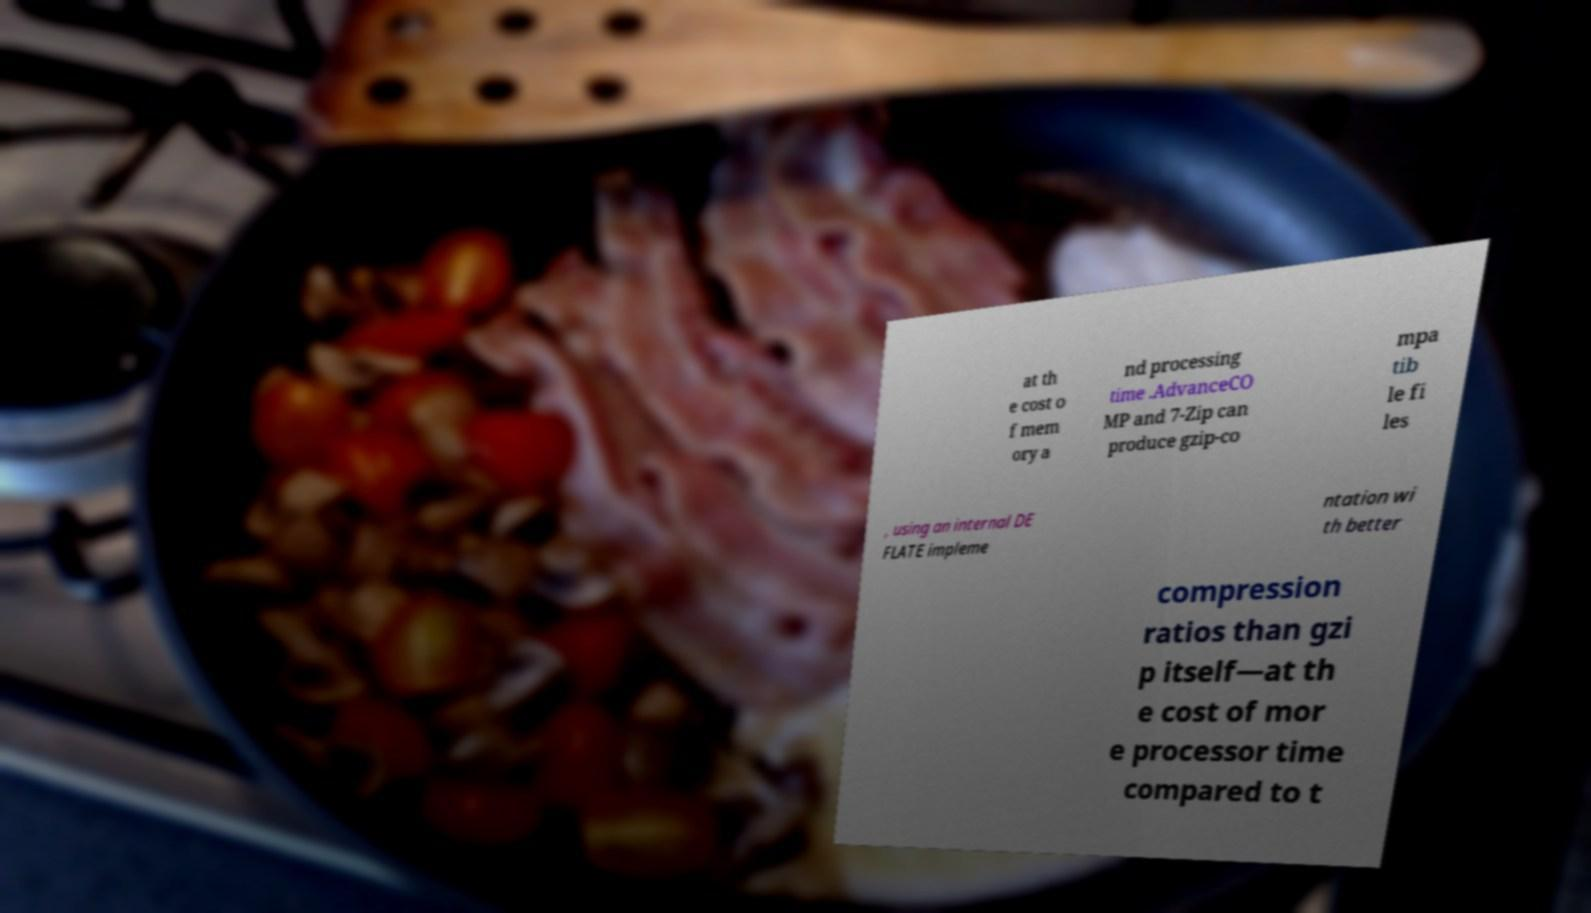Could you assist in decoding the text presented in this image and type it out clearly? at th e cost o f mem ory a nd processing time .AdvanceCO MP and 7-Zip can produce gzip-co mpa tib le fi les , using an internal DE FLATE impleme ntation wi th better compression ratios than gzi p itself—at th e cost of mor e processor time compared to t 